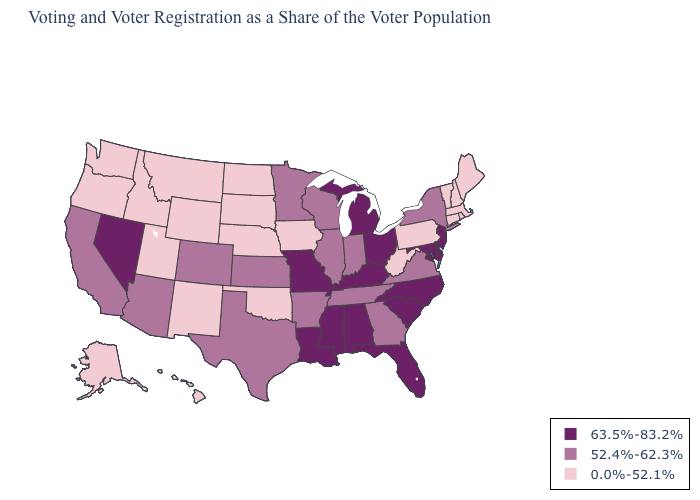Among the states that border Illinois , which have the lowest value?
Answer briefly. Iowa. What is the value of New Mexico?
Write a very short answer. 0.0%-52.1%. Which states have the lowest value in the MidWest?
Give a very brief answer. Iowa, Nebraska, North Dakota, South Dakota. Name the states that have a value in the range 52.4%-62.3%?
Be succinct. Arizona, Arkansas, California, Colorado, Georgia, Illinois, Indiana, Kansas, Minnesota, New York, Tennessee, Texas, Virginia, Wisconsin. What is the lowest value in states that border Oklahoma?
Write a very short answer. 0.0%-52.1%. Does New Mexico have the lowest value in the USA?
Quick response, please. Yes. Name the states that have a value in the range 63.5%-83.2%?
Answer briefly. Alabama, Delaware, Florida, Kentucky, Louisiana, Maryland, Michigan, Mississippi, Missouri, Nevada, New Jersey, North Carolina, Ohio, South Carolina. What is the value of Pennsylvania?
Answer briefly. 0.0%-52.1%. Does Pennsylvania have the highest value in the USA?
Keep it brief. No. Does Michigan have a higher value than Idaho?
Answer briefly. Yes. Which states hav the highest value in the West?
Write a very short answer. Nevada. Which states have the lowest value in the USA?
Write a very short answer. Alaska, Connecticut, Hawaii, Idaho, Iowa, Maine, Massachusetts, Montana, Nebraska, New Hampshire, New Mexico, North Dakota, Oklahoma, Oregon, Pennsylvania, Rhode Island, South Dakota, Utah, Vermont, Washington, West Virginia, Wyoming. Does Utah have the highest value in the USA?
Be succinct. No. Which states have the lowest value in the South?
Short answer required. Oklahoma, West Virginia. 